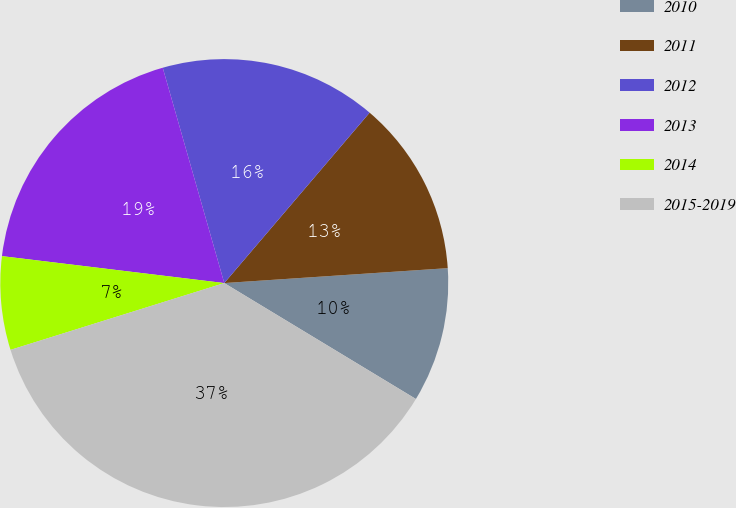Convert chart to OTSL. <chart><loc_0><loc_0><loc_500><loc_500><pie_chart><fcel>2010<fcel>2011<fcel>2012<fcel>2013<fcel>2014<fcel>2015-2019<nl><fcel>9.72%<fcel>12.7%<fcel>15.67%<fcel>18.65%<fcel>6.74%<fcel>36.52%<nl></chart> 